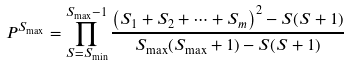Convert formula to latex. <formula><loc_0><loc_0><loc_500><loc_500>P ^ { S _ { \max } } = \prod _ { S = S _ { \min } } ^ { S _ { \max } - 1 } \frac { \left ( { S } _ { 1 } + { S } _ { 2 } + \cdots + { S } _ { m } \right ) ^ { 2 } - S ( S + 1 ) } { S _ { \max } ( S _ { \max } + 1 ) - S ( S + 1 ) }</formula> 